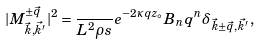Convert formula to latex. <formula><loc_0><loc_0><loc_500><loc_500>| M _ { { \vec { k } } , { \vec { k ^ { \prime } } } } ^ { \pm \vec { q } } | ^ { 2 } = \frac { } { L ^ { 2 } \rho s } e ^ { - 2 \kappa q z _ { \circ } } B _ { n } q ^ { n } \delta _ { \vec { k } \pm \vec { q } , \vec { k ^ { \prime } } } \, ,</formula> 